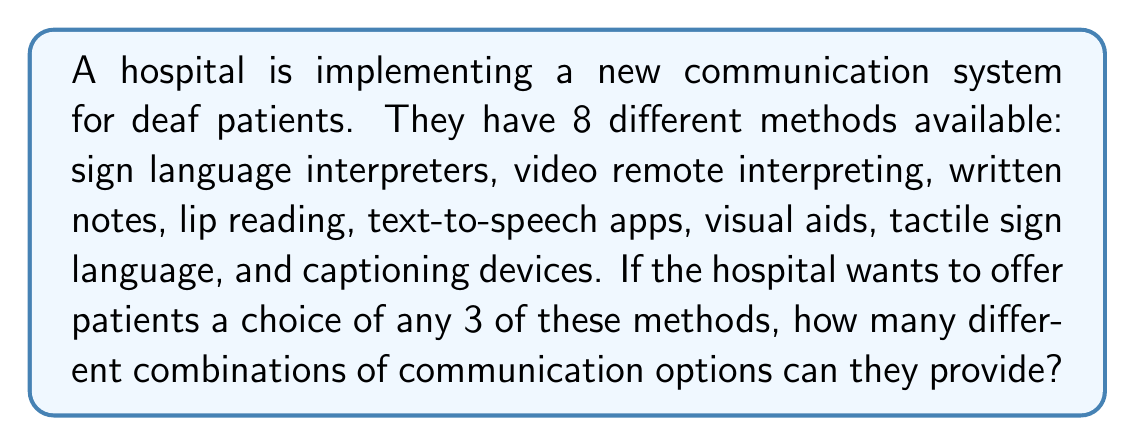Help me with this question. To solve this problem, we need to use the combination formula. We are selecting 3 methods out of 8 available methods, where the order doesn't matter (as we're just offering options, not ranking them).

The formula for combinations is:

$$C(n,r) = \frac{n!}{r!(n-r)!}$$

Where:
$n$ is the total number of items to choose from (in this case, 8 communication methods)
$r$ is the number of items being chosen (in this case, 3 methods)

Let's plug in our values:

$$C(8,3) = \frac{8!}{3!(8-3)!} = \frac{8!}{3!5!}$$

Now, let's calculate this step by step:

1) First, expand this:
   $$\frac{8 * 7 * 6 * 5!}{(3 * 2 * 1) * 5!}$$

2) The 5! cancels out in the numerator and denominator:
   $$\frac{8 * 7 * 6}{3 * 2 * 1}$$

3) Multiply the numerator and denominator:
   $$\frac{336}{6}$$

4) Divide:
   $$56$$

Therefore, the hospital can offer 56 different combinations of 3 communication methods to deaf patients.
Answer: 56 combinations 